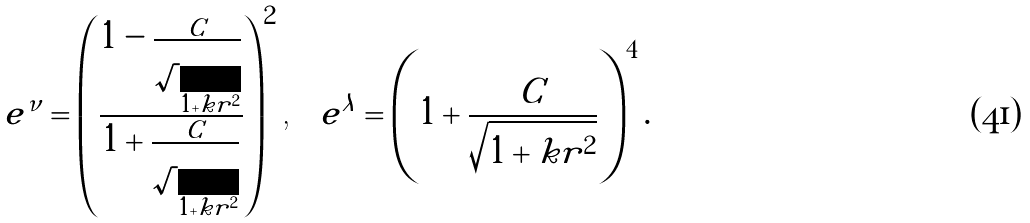Convert formula to latex. <formula><loc_0><loc_0><loc_500><loc_500>e ^ { \nu } = \left ( \frac { 1 - \frac { C } { \sqrt { 1 + k r ^ { 2 } } } } { 1 + \frac { C } { \sqrt { 1 + k r ^ { 2 } } } } \right ) ^ { 2 } \text {,} \quad e ^ { \lambda } = \left ( 1 + \frac { C } { \sqrt { 1 + k r ^ { 2 } } } \right ) ^ { 4 } .</formula> 